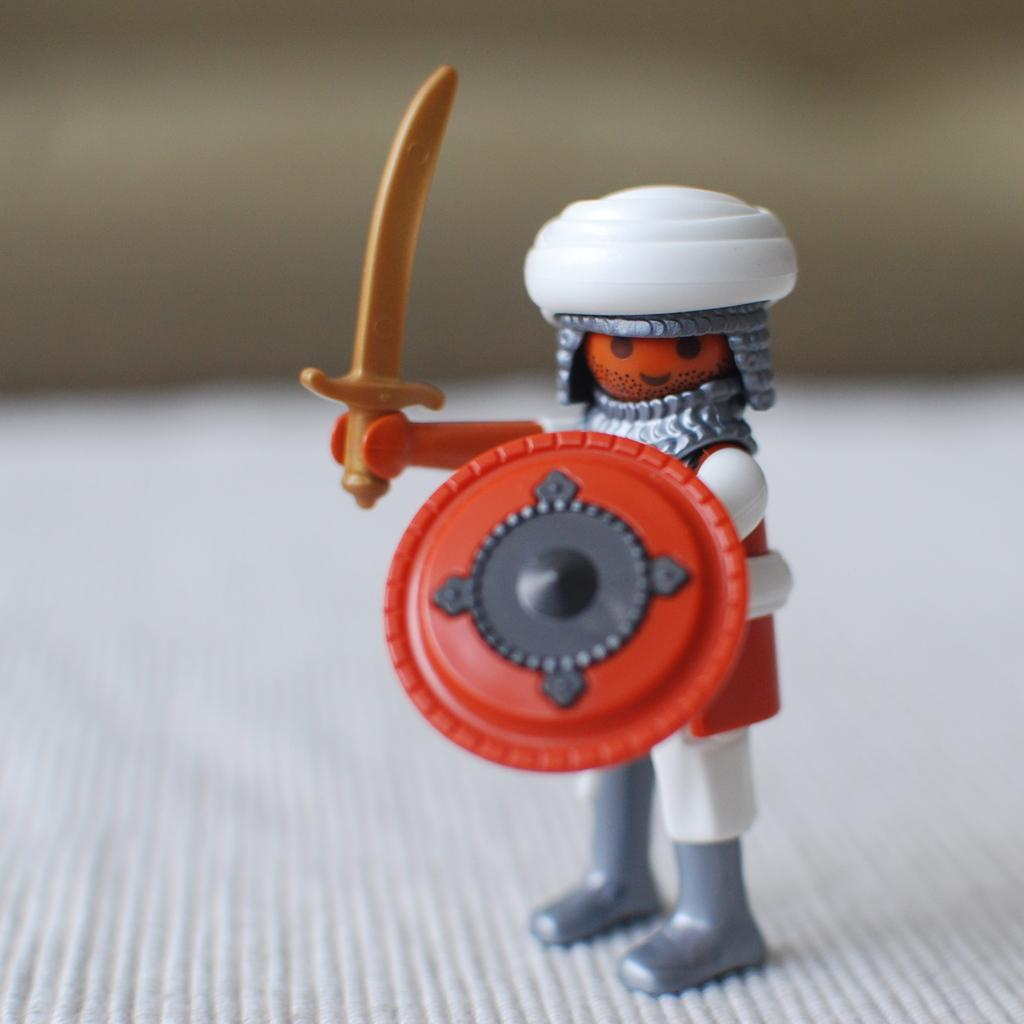What is the main subject of the picture? The main subject of the picture is a miniature. Can you describe the background of the picture? The background of the picture is blurry. How many frogs can be seen resting on the miniature in the image? There are no frogs present in the image, and therefore no such activity can be observed. 